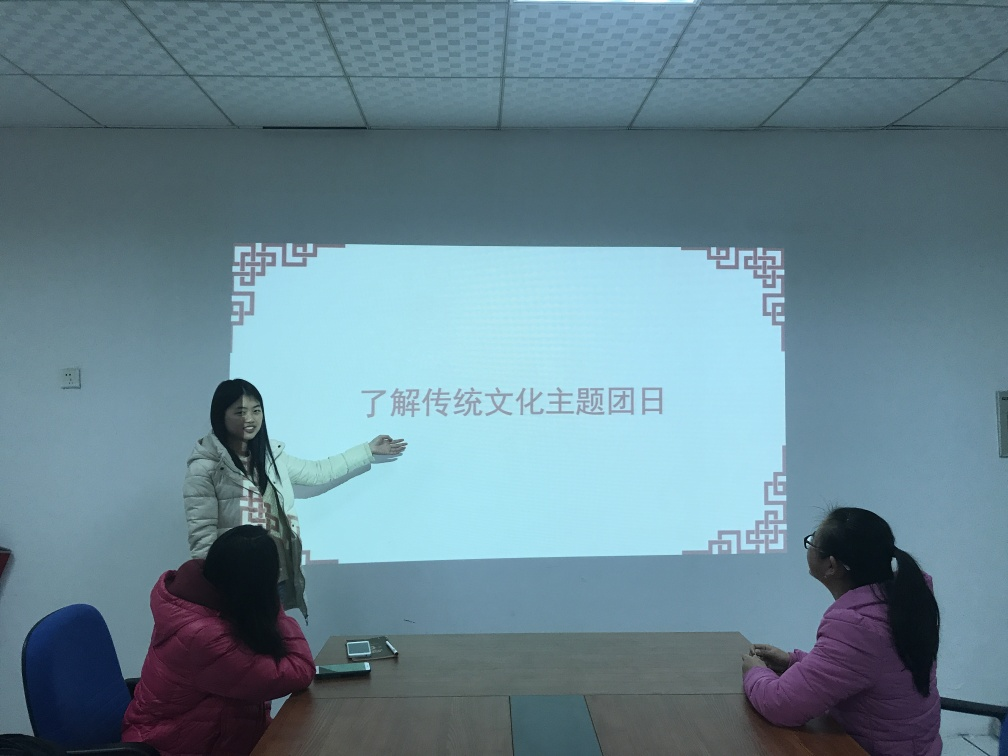Can you describe the setting of this image? The setting is an indoor space, likely a meeting room or classroom, with plain walls and a large projection screen displaying text that suggests an educational or professional context. What might be the topic of the presentation? The content on the screen appears to be in a non-English script, which may not be readable to all viewers. However, the setting implies it could be a topic related to education, professional training, or a business-related subject matter. 